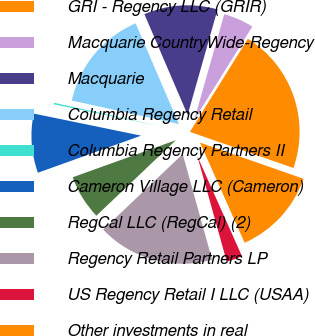Convert chart. <chart><loc_0><loc_0><loc_500><loc_500><pie_chart><fcel>GRI - Regency LLC (GRIR)<fcel>Macquarie CountryWide-Regency<fcel>Macquarie<fcel>Columbia Regency Retail<fcel>Columbia Regency Partners II<fcel>Cameron Village LLC (Cameron)<fcel>RegCal LLC (RegCal) (2)<fcel>Regency Retail Partners LP<fcel>US Regency Retail I LLC (USAA)<fcel>Other investments in real<nl><fcel>21.48%<fcel>4.47%<fcel>10.85%<fcel>15.1%<fcel>0.22%<fcel>8.72%<fcel>6.6%<fcel>17.23%<fcel>2.35%<fcel>12.98%<nl></chart> 